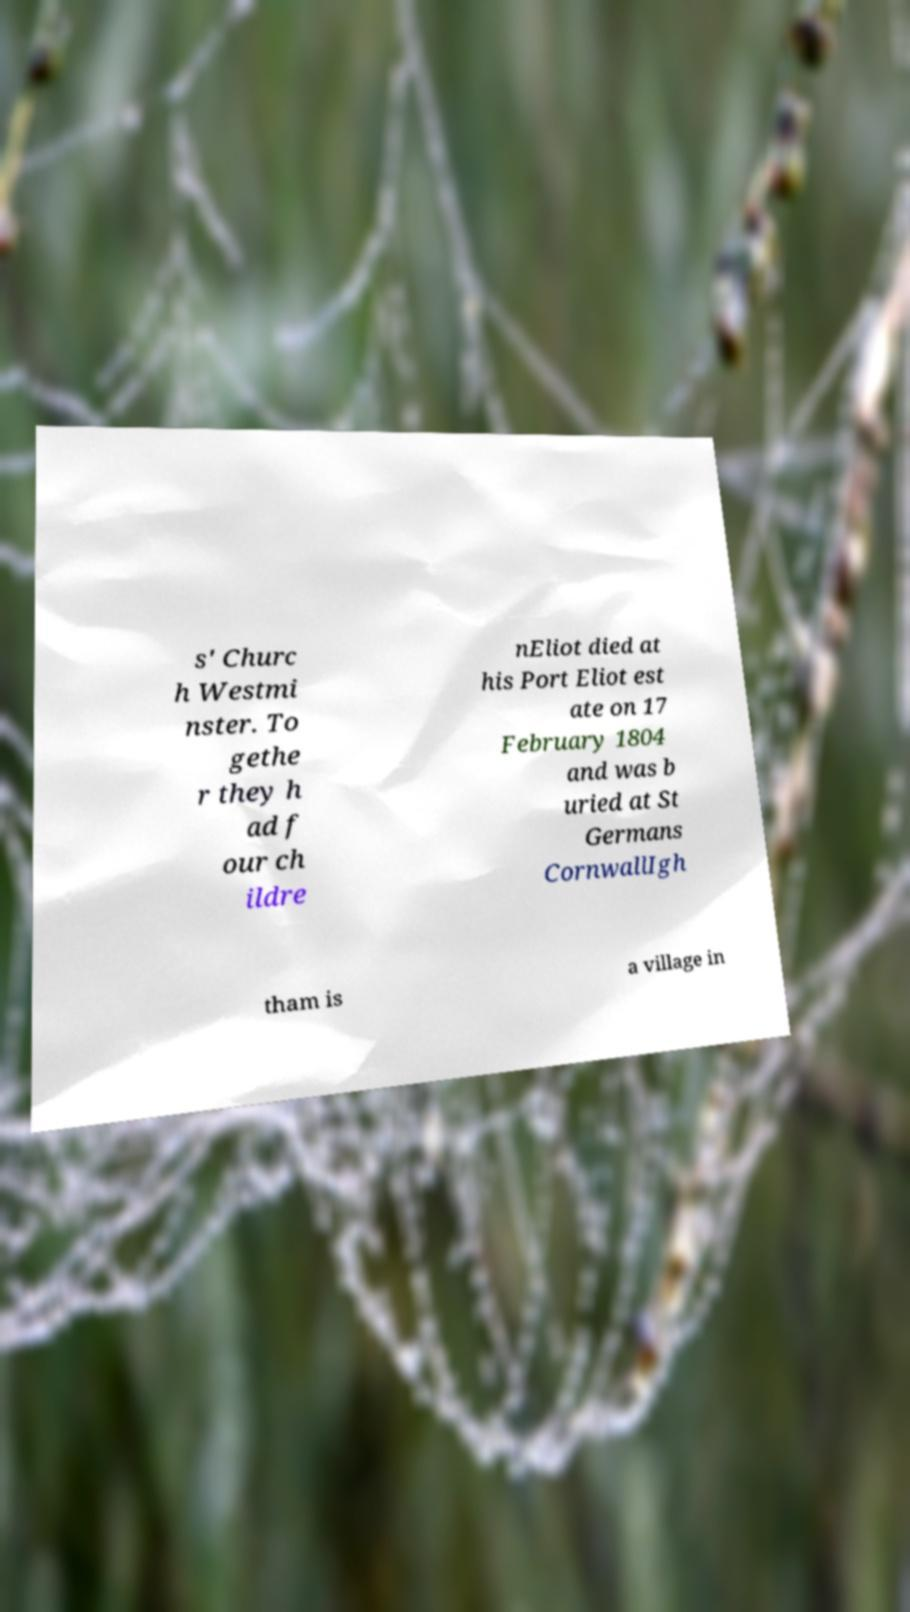For documentation purposes, I need the text within this image transcribed. Could you provide that? s' Churc h Westmi nster. To gethe r they h ad f our ch ildre nEliot died at his Port Eliot est ate on 17 February 1804 and was b uried at St Germans CornwallIgh tham is a village in 